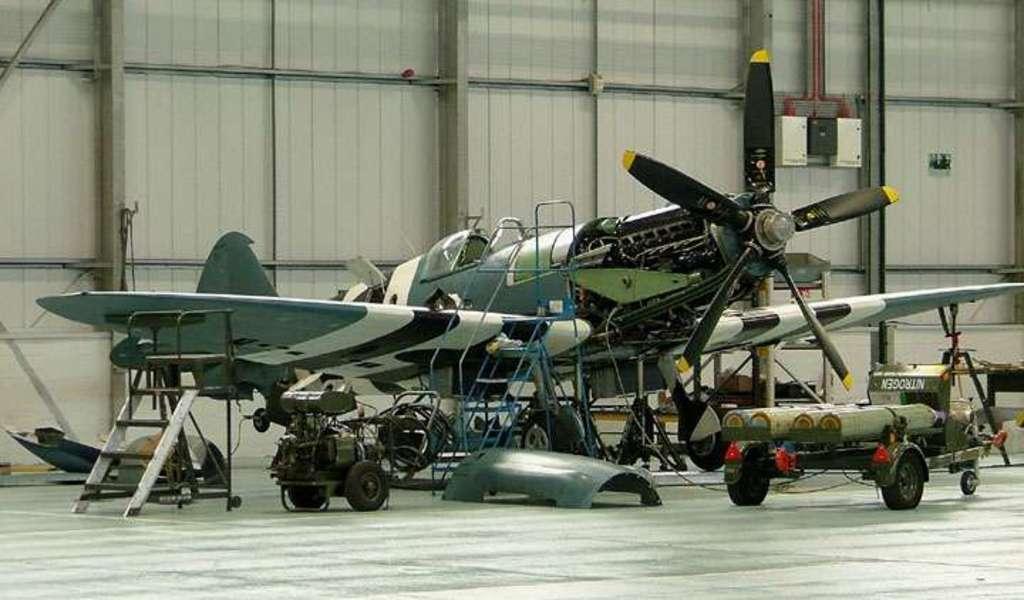Please provide a concise description of this image. In we can see a flying jet. This is a floor, wall and these are the tires of the flying jet. 